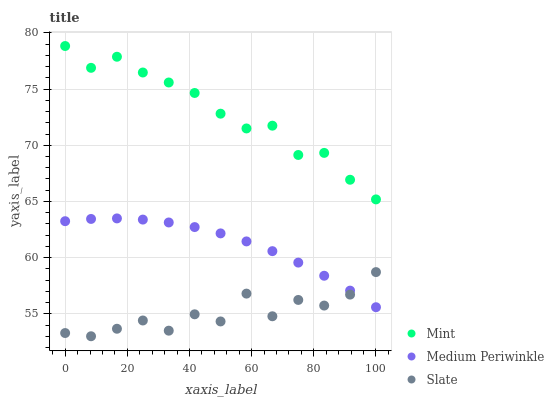Does Slate have the minimum area under the curve?
Answer yes or no. Yes. Does Mint have the maximum area under the curve?
Answer yes or no. Yes. Does Mint have the minimum area under the curve?
Answer yes or no. No. Does Slate have the maximum area under the curve?
Answer yes or no. No. Is Medium Periwinkle the smoothest?
Answer yes or no. Yes. Is Slate the roughest?
Answer yes or no. Yes. Is Mint the smoothest?
Answer yes or no. No. Is Mint the roughest?
Answer yes or no. No. Does Slate have the lowest value?
Answer yes or no. Yes. Does Mint have the lowest value?
Answer yes or no. No. Does Mint have the highest value?
Answer yes or no. Yes. Does Slate have the highest value?
Answer yes or no. No. Is Slate less than Mint?
Answer yes or no. Yes. Is Mint greater than Slate?
Answer yes or no. Yes. Does Slate intersect Medium Periwinkle?
Answer yes or no. Yes. Is Slate less than Medium Periwinkle?
Answer yes or no. No. Is Slate greater than Medium Periwinkle?
Answer yes or no. No. Does Slate intersect Mint?
Answer yes or no. No. 